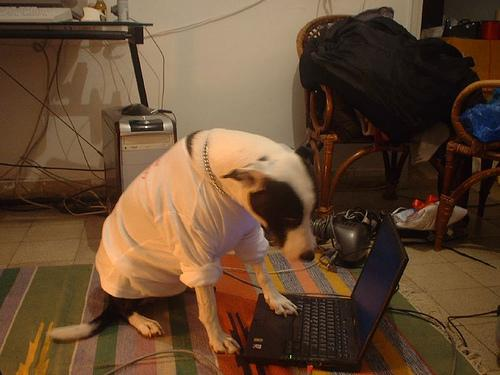What is the dog's paw resting on? Please explain your reasoning. keyboard. A dog sits in front a laptop with a paw on the keyboard. 